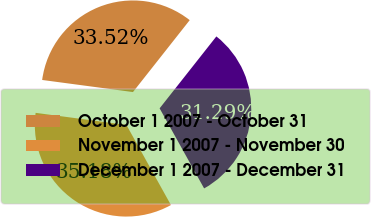Convert chart to OTSL. <chart><loc_0><loc_0><loc_500><loc_500><pie_chart><fcel>October 1 2007 - October 31<fcel>November 1 2007 - November 30<fcel>December 1 2007 - December 31<nl><fcel>33.52%<fcel>35.18%<fcel>31.29%<nl></chart> 